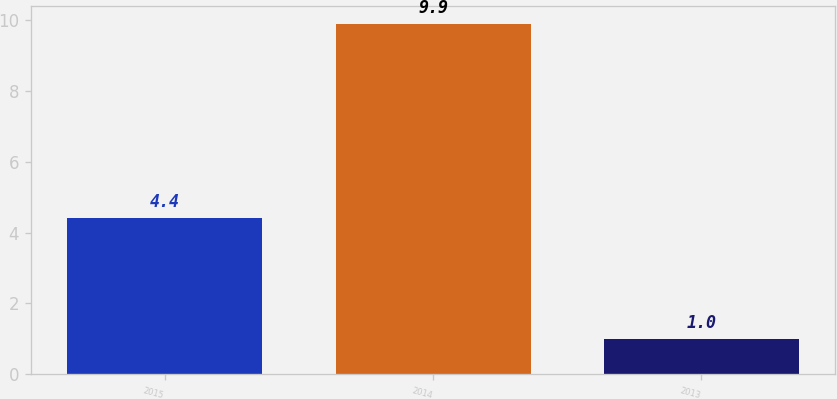Convert chart to OTSL. <chart><loc_0><loc_0><loc_500><loc_500><bar_chart><fcel>2015<fcel>2014<fcel>2013<nl><fcel>4.4<fcel>9.9<fcel>1<nl></chart> 